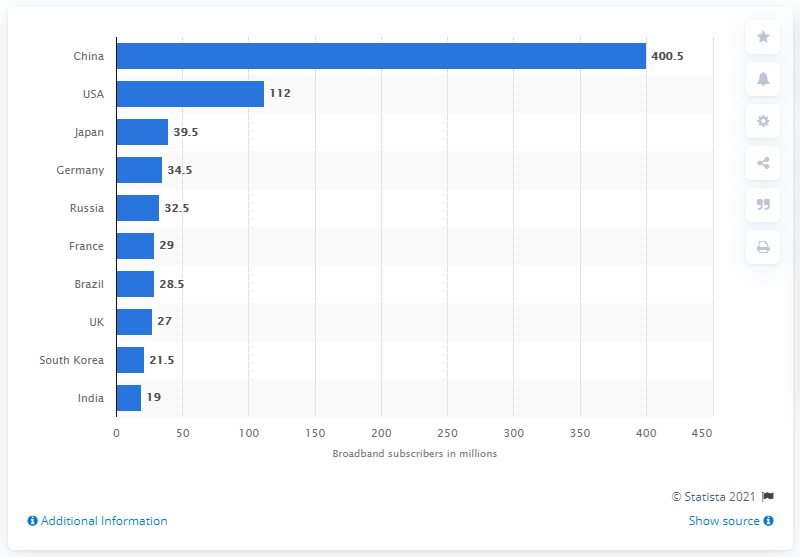Draw attention to some important aspects in this diagram. In the first quarter of 2019, there were 400,500 fixed broadband subscribers in China. 